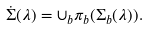Convert formula to latex. <formula><loc_0><loc_0><loc_500><loc_500>\dot { \Sigma } ( \lambda ) = \cup _ { b } \pi _ { b } ( \Sigma _ { b } ( \lambda ) ) .</formula> 